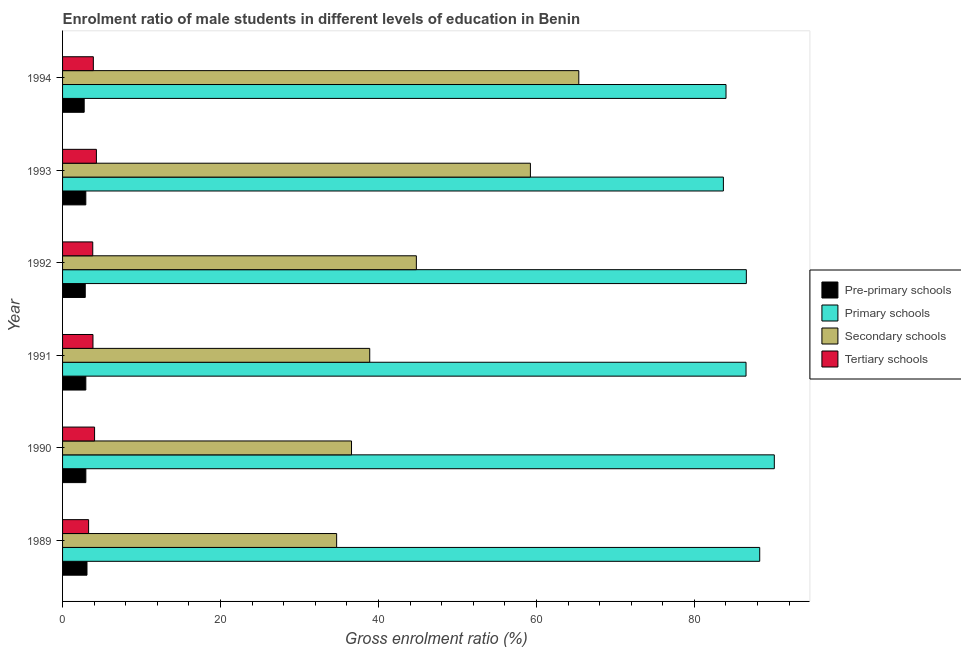How many different coloured bars are there?
Your answer should be compact. 4. How many groups of bars are there?
Offer a terse response. 6. How many bars are there on the 3rd tick from the bottom?
Make the answer very short. 4. What is the label of the 6th group of bars from the top?
Make the answer very short. 1989. In how many cases, is the number of bars for a given year not equal to the number of legend labels?
Your response must be concise. 0. What is the gross enrolment ratio(female) in primary schools in 1990?
Make the answer very short. 90.12. Across all years, what is the maximum gross enrolment ratio(female) in pre-primary schools?
Provide a succinct answer. 3.09. Across all years, what is the minimum gross enrolment ratio(female) in primary schools?
Keep it short and to the point. 83.67. In which year was the gross enrolment ratio(female) in primary schools maximum?
Give a very brief answer. 1990. In which year was the gross enrolment ratio(female) in secondary schools minimum?
Ensure brevity in your answer.  1989. What is the total gross enrolment ratio(female) in primary schools in the graph?
Ensure brevity in your answer.  519.18. What is the difference between the gross enrolment ratio(female) in tertiary schools in 1993 and that in 1994?
Make the answer very short. 0.39. What is the difference between the gross enrolment ratio(female) in pre-primary schools in 1989 and the gross enrolment ratio(female) in tertiary schools in 1994?
Give a very brief answer. -0.8. What is the average gross enrolment ratio(female) in secondary schools per year?
Offer a terse response. 46.6. In the year 1990, what is the difference between the gross enrolment ratio(female) in primary schools and gross enrolment ratio(female) in pre-primary schools?
Offer a terse response. 87.17. What is the ratio of the gross enrolment ratio(female) in tertiary schools in 1990 to that in 1992?
Offer a terse response. 1.06. Is the gross enrolment ratio(female) in primary schools in 1989 less than that in 1993?
Offer a terse response. No. Is the difference between the gross enrolment ratio(female) in tertiary schools in 1991 and 1992 greater than the difference between the gross enrolment ratio(female) in pre-primary schools in 1991 and 1992?
Give a very brief answer. No. What is the difference between the highest and the second highest gross enrolment ratio(female) in primary schools?
Keep it short and to the point. 1.85. What does the 1st bar from the top in 1989 represents?
Provide a succinct answer. Tertiary schools. What does the 4th bar from the bottom in 1993 represents?
Offer a very short reply. Tertiary schools. Is it the case that in every year, the sum of the gross enrolment ratio(female) in pre-primary schools and gross enrolment ratio(female) in primary schools is greater than the gross enrolment ratio(female) in secondary schools?
Keep it short and to the point. Yes. How many bars are there?
Your response must be concise. 24. Does the graph contain grids?
Keep it short and to the point. No. Where does the legend appear in the graph?
Offer a terse response. Center right. How many legend labels are there?
Your answer should be very brief. 4. How are the legend labels stacked?
Ensure brevity in your answer.  Vertical. What is the title of the graph?
Provide a succinct answer. Enrolment ratio of male students in different levels of education in Benin. Does "Third 20% of population" appear as one of the legend labels in the graph?
Ensure brevity in your answer.  No. What is the label or title of the X-axis?
Offer a terse response. Gross enrolment ratio (%). What is the Gross enrolment ratio (%) of Pre-primary schools in 1989?
Give a very brief answer. 3.09. What is the Gross enrolment ratio (%) in Primary schools in 1989?
Your response must be concise. 88.27. What is the Gross enrolment ratio (%) in Secondary schools in 1989?
Make the answer very short. 34.7. What is the Gross enrolment ratio (%) of Tertiary schools in 1989?
Make the answer very short. 3.3. What is the Gross enrolment ratio (%) of Pre-primary schools in 1990?
Make the answer very short. 2.95. What is the Gross enrolment ratio (%) of Primary schools in 1990?
Your answer should be compact. 90.12. What is the Gross enrolment ratio (%) of Secondary schools in 1990?
Your answer should be compact. 36.59. What is the Gross enrolment ratio (%) in Tertiary schools in 1990?
Offer a very short reply. 4.05. What is the Gross enrolment ratio (%) of Pre-primary schools in 1991?
Offer a very short reply. 2.95. What is the Gross enrolment ratio (%) in Primary schools in 1991?
Give a very brief answer. 86.54. What is the Gross enrolment ratio (%) of Secondary schools in 1991?
Your response must be concise. 38.89. What is the Gross enrolment ratio (%) in Tertiary schools in 1991?
Keep it short and to the point. 3.85. What is the Gross enrolment ratio (%) of Pre-primary schools in 1992?
Your response must be concise. 2.87. What is the Gross enrolment ratio (%) in Primary schools in 1992?
Keep it short and to the point. 86.58. What is the Gross enrolment ratio (%) of Secondary schools in 1992?
Give a very brief answer. 44.8. What is the Gross enrolment ratio (%) in Tertiary schools in 1992?
Your response must be concise. 3.82. What is the Gross enrolment ratio (%) in Pre-primary schools in 1993?
Ensure brevity in your answer.  2.94. What is the Gross enrolment ratio (%) in Primary schools in 1993?
Your answer should be very brief. 83.67. What is the Gross enrolment ratio (%) of Secondary schools in 1993?
Your answer should be compact. 59.24. What is the Gross enrolment ratio (%) of Tertiary schools in 1993?
Your response must be concise. 4.29. What is the Gross enrolment ratio (%) of Pre-primary schools in 1994?
Keep it short and to the point. 2.74. What is the Gross enrolment ratio (%) in Primary schools in 1994?
Offer a very short reply. 84. What is the Gross enrolment ratio (%) of Secondary schools in 1994?
Offer a terse response. 65.36. What is the Gross enrolment ratio (%) of Tertiary schools in 1994?
Your answer should be compact. 3.9. Across all years, what is the maximum Gross enrolment ratio (%) in Pre-primary schools?
Ensure brevity in your answer.  3.09. Across all years, what is the maximum Gross enrolment ratio (%) in Primary schools?
Ensure brevity in your answer.  90.12. Across all years, what is the maximum Gross enrolment ratio (%) of Secondary schools?
Your answer should be very brief. 65.36. Across all years, what is the maximum Gross enrolment ratio (%) in Tertiary schools?
Provide a short and direct response. 4.29. Across all years, what is the minimum Gross enrolment ratio (%) in Pre-primary schools?
Your answer should be compact. 2.74. Across all years, what is the minimum Gross enrolment ratio (%) in Primary schools?
Make the answer very short. 83.67. Across all years, what is the minimum Gross enrolment ratio (%) in Secondary schools?
Provide a short and direct response. 34.7. Across all years, what is the minimum Gross enrolment ratio (%) in Tertiary schools?
Offer a very short reply. 3.3. What is the total Gross enrolment ratio (%) in Pre-primary schools in the graph?
Provide a succinct answer. 17.54. What is the total Gross enrolment ratio (%) in Primary schools in the graph?
Your response must be concise. 519.18. What is the total Gross enrolment ratio (%) in Secondary schools in the graph?
Give a very brief answer. 279.58. What is the total Gross enrolment ratio (%) in Tertiary schools in the graph?
Provide a succinct answer. 23.2. What is the difference between the Gross enrolment ratio (%) in Pre-primary schools in 1989 and that in 1990?
Give a very brief answer. 0.14. What is the difference between the Gross enrolment ratio (%) in Primary schools in 1989 and that in 1990?
Keep it short and to the point. -1.85. What is the difference between the Gross enrolment ratio (%) in Secondary schools in 1989 and that in 1990?
Provide a succinct answer. -1.88. What is the difference between the Gross enrolment ratio (%) in Tertiary schools in 1989 and that in 1990?
Your answer should be compact. -0.76. What is the difference between the Gross enrolment ratio (%) of Pre-primary schools in 1989 and that in 1991?
Keep it short and to the point. 0.15. What is the difference between the Gross enrolment ratio (%) in Primary schools in 1989 and that in 1991?
Your answer should be compact. 1.73. What is the difference between the Gross enrolment ratio (%) of Secondary schools in 1989 and that in 1991?
Ensure brevity in your answer.  -4.19. What is the difference between the Gross enrolment ratio (%) of Tertiary schools in 1989 and that in 1991?
Your answer should be compact. -0.55. What is the difference between the Gross enrolment ratio (%) in Pre-primary schools in 1989 and that in 1992?
Give a very brief answer. 0.22. What is the difference between the Gross enrolment ratio (%) of Primary schools in 1989 and that in 1992?
Make the answer very short. 1.7. What is the difference between the Gross enrolment ratio (%) in Secondary schools in 1989 and that in 1992?
Offer a terse response. -10.09. What is the difference between the Gross enrolment ratio (%) of Tertiary schools in 1989 and that in 1992?
Offer a terse response. -0.52. What is the difference between the Gross enrolment ratio (%) in Pre-primary schools in 1989 and that in 1993?
Your answer should be very brief. 0.15. What is the difference between the Gross enrolment ratio (%) in Primary schools in 1989 and that in 1993?
Make the answer very short. 4.6. What is the difference between the Gross enrolment ratio (%) of Secondary schools in 1989 and that in 1993?
Your answer should be compact. -24.53. What is the difference between the Gross enrolment ratio (%) in Tertiary schools in 1989 and that in 1993?
Make the answer very short. -0.99. What is the difference between the Gross enrolment ratio (%) of Pre-primary schools in 1989 and that in 1994?
Offer a terse response. 0.35. What is the difference between the Gross enrolment ratio (%) of Primary schools in 1989 and that in 1994?
Give a very brief answer. 4.27. What is the difference between the Gross enrolment ratio (%) in Secondary schools in 1989 and that in 1994?
Your answer should be very brief. -30.66. What is the difference between the Gross enrolment ratio (%) in Tertiary schools in 1989 and that in 1994?
Your answer should be compact. -0.6. What is the difference between the Gross enrolment ratio (%) in Pre-primary schools in 1990 and that in 1991?
Give a very brief answer. 0. What is the difference between the Gross enrolment ratio (%) in Primary schools in 1990 and that in 1991?
Ensure brevity in your answer.  3.58. What is the difference between the Gross enrolment ratio (%) in Secondary schools in 1990 and that in 1991?
Your response must be concise. -2.31. What is the difference between the Gross enrolment ratio (%) of Tertiary schools in 1990 and that in 1991?
Give a very brief answer. 0.2. What is the difference between the Gross enrolment ratio (%) of Pre-primary schools in 1990 and that in 1992?
Provide a short and direct response. 0.08. What is the difference between the Gross enrolment ratio (%) of Primary schools in 1990 and that in 1992?
Ensure brevity in your answer.  3.54. What is the difference between the Gross enrolment ratio (%) of Secondary schools in 1990 and that in 1992?
Keep it short and to the point. -8.21. What is the difference between the Gross enrolment ratio (%) in Tertiary schools in 1990 and that in 1992?
Provide a succinct answer. 0.23. What is the difference between the Gross enrolment ratio (%) in Pre-primary schools in 1990 and that in 1993?
Your response must be concise. 0. What is the difference between the Gross enrolment ratio (%) in Primary schools in 1990 and that in 1993?
Your response must be concise. 6.45. What is the difference between the Gross enrolment ratio (%) in Secondary schools in 1990 and that in 1993?
Keep it short and to the point. -22.65. What is the difference between the Gross enrolment ratio (%) of Tertiary schools in 1990 and that in 1993?
Your response must be concise. -0.23. What is the difference between the Gross enrolment ratio (%) of Pre-primary schools in 1990 and that in 1994?
Provide a succinct answer. 0.21. What is the difference between the Gross enrolment ratio (%) in Primary schools in 1990 and that in 1994?
Keep it short and to the point. 6.11. What is the difference between the Gross enrolment ratio (%) in Secondary schools in 1990 and that in 1994?
Offer a terse response. -28.78. What is the difference between the Gross enrolment ratio (%) in Tertiary schools in 1990 and that in 1994?
Your response must be concise. 0.16. What is the difference between the Gross enrolment ratio (%) of Pre-primary schools in 1991 and that in 1992?
Your answer should be very brief. 0.07. What is the difference between the Gross enrolment ratio (%) in Primary schools in 1991 and that in 1992?
Keep it short and to the point. -0.04. What is the difference between the Gross enrolment ratio (%) of Secondary schools in 1991 and that in 1992?
Your answer should be compact. -5.9. What is the difference between the Gross enrolment ratio (%) in Tertiary schools in 1991 and that in 1992?
Give a very brief answer. 0.03. What is the difference between the Gross enrolment ratio (%) in Pre-primary schools in 1991 and that in 1993?
Provide a short and direct response. 0. What is the difference between the Gross enrolment ratio (%) in Primary schools in 1991 and that in 1993?
Your answer should be compact. 2.87. What is the difference between the Gross enrolment ratio (%) in Secondary schools in 1991 and that in 1993?
Offer a terse response. -20.34. What is the difference between the Gross enrolment ratio (%) in Tertiary schools in 1991 and that in 1993?
Offer a very short reply. -0.44. What is the difference between the Gross enrolment ratio (%) in Pre-primary schools in 1991 and that in 1994?
Provide a short and direct response. 0.21. What is the difference between the Gross enrolment ratio (%) in Primary schools in 1991 and that in 1994?
Your answer should be very brief. 2.53. What is the difference between the Gross enrolment ratio (%) in Secondary schools in 1991 and that in 1994?
Your response must be concise. -26.47. What is the difference between the Gross enrolment ratio (%) of Tertiary schools in 1991 and that in 1994?
Your answer should be very brief. -0.05. What is the difference between the Gross enrolment ratio (%) of Pre-primary schools in 1992 and that in 1993?
Provide a succinct answer. -0.07. What is the difference between the Gross enrolment ratio (%) in Primary schools in 1992 and that in 1993?
Make the answer very short. 2.9. What is the difference between the Gross enrolment ratio (%) in Secondary schools in 1992 and that in 1993?
Provide a short and direct response. -14.44. What is the difference between the Gross enrolment ratio (%) in Tertiary schools in 1992 and that in 1993?
Keep it short and to the point. -0.46. What is the difference between the Gross enrolment ratio (%) in Pre-primary schools in 1992 and that in 1994?
Your answer should be compact. 0.13. What is the difference between the Gross enrolment ratio (%) of Primary schools in 1992 and that in 1994?
Your response must be concise. 2.57. What is the difference between the Gross enrolment ratio (%) of Secondary schools in 1992 and that in 1994?
Provide a succinct answer. -20.57. What is the difference between the Gross enrolment ratio (%) in Tertiary schools in 1992 and that in 1994?
Your answer should be compact. -0.07. What is the difference between the Gross enrolment ratio (%) of Pre-primary schools in 1993 and that in 1994?
Give a very brief answer. 0.21. What is the difference between the Gross enrolment ratio (%) in Primary schools in 1993 and that in 1994?
Give a very brief answer. -0.33. What is the difference between the Gross enrolment ratio (%) of Secondary schools in 1993 and that in 1994?
Your answer should be compact. -6.13. What is the difference between the Gross enrolment ratio (%) of Tertiary schools in 1993 and that in 1994?
Offer a terse response. 0.39. What is the difference between the Gross enrolment ratio (%) of Pre-primary schools in 1989 and the Gross enrolment ratio (%) of Primary schools in 1990?
Your answer should be very brief. -87.03. What is the difference between the Gross enrolment ratio (%) in Pre-primary schools in 1989 and the Gross enrolment ratio (%) in Secondary schools in 1990?
Provide a short and direct response. -33.49. What is the difference between the Gross enrolment ratio (%) in Pre-primary schools in 1989 and the Gross enrolment ratio (%) in Tertiary schools in 1990?
Make the answer very short. -0.96. What is the difference between the Gross enrolment ratio (%) in Primary schools in 1989 and the Gross enrolment ratio (%) in Secondary schools in 1990?
Your response must be concise. 51.69. What is the difference between the Gross enrolment ratio (%) of Primary schools in 1989 and the Gross enrolment ratio (%) of Tertiary schools in 1990?
Keep it short and to the point. 84.22. What is the difference between the Gross enrolment ratio (%) in Secondary schools in 1989 and the Gross enrolment ratio (%) in Tertiary schools in 1990?
Offer a very short reply. 30.65. What is the difference between the Gross enrolment ratio (%) in Pre-primary schools in 1989 and the Gross enrolment ratio (%) in Primary schools in 1991?
Provide a short and direct response. -83.45. What is the difference between the Gross enrolment ratio (%) in Pre-primary schools in 1989 and the Gross enrolment ratio (%) in Secondary schools in 1991?
Give a very brief answer. -35.8. What is the difference between the Gross enrolment ratio (%) of Pre-primary schools in 1989 and the Gross enrolment ratio (%) of Tertiary schools in 1991?
Your answer should be very brief. -0.76. What is the difference between the Gross enrolment ratio (%) in Primary schools in 1989 and the Gross enrolment ratio (%) in Secondary schools in 1991?
Provide a succinct answer. 49.38. What is the difference between the Gross enrolment ratio (%) of Primary schools in 1989 and the Gross enrolment ratio (%) of Tertiary schools in 1991?
Give a very brief answer. 84.42. What is the difference between the Gross enrolment ratio (%) of Secondary schools in 1989 and the Gross enrolment ratio (%) of Tertiary schools in 1991?
Offer a very short reply. 30.85. What is the difference between the Gross enrolment ratio (%) in Pre-primary schools in 1989 and the Gross enrolment ratio (%) in Primary schools in 1992?
Your answer should be compact. -83.48. What is the difference between the Gross enrolment ratio (%) of Pre-primary schools in 1989 and the Gross enrolment ratio (%) of Secondary schools in 1992?
Your answer should be very brief. -41.7. What is the difference between the Gross enrolment ratio (%) in Pre-primary schools in 1989 and the Gross enrolment ratio (%) in Tertiary schools in 1992?
Your response must be concise. -0.73. What is the difference between the Gross enrolment ratio (%) of Primary schools in 1989 and the Gross enrolment ratio (%) of Secondary schools in 1992?
Keep it short and to the point. 43.48. What is the difference between the Gross enrolment ratio (%) of Primary schools in 1989 and the Gross enrolment ratio (%) of Tertiary schools in 1992?
Offer a very short reply. 84.45. What is the difference between the Gross enrolment ratio (%) in Secondary schools in 1989 and the Gross enrolment ratio (%) in Tertiary schools in 1992?
Your response must be concise. 30.88. What is the difference between the Gross enrolment ratio (%) in Pre-primary schools in 1989 and the Gross enrolment ratio (%) in Primary schools in 1993?
Provide a short and direct response. -80.58. What is the difference between the Gross enrolment ratio (%) of Pre-primary schools in 1989 and the Gross enrolment ratio (%) of Secondary schools in 1993?
Keep it short and to the point. -56.14. What is the difference between the Gross enrolment ratio (%) in Pre-primary schools in 1989 and the Gross enrolment ratio (%) in Tertiary schools in 1993?
Your answer should be compact. -1.19. What is the difference between the Gross enrolment ratio (%) of Primary schools in 1989 and the Gross enrolment ratio (%) of Secondary schools in 1993?
Your response must be concise. 29.04. What is the difference between the Gross enrolment ratio (%) of Primary schools in 1989 and the Gross enrolment ratio (%) of Tertiary schools in 1993?
Provide a short and direct response. 83.99. What is the difference between the Gross enrolment ratio (%) in Secondary schools in 1989 and the Gross enrolment ratio (%) in Tertiary schools in 1993?
Your response must be concise. 30.42. What is the difference between the Gross enrolment ratio (%) in Pre-primary schools in 1989 and the Gross enrolment ratio (%) in Primary schools in 1994?
Your answer should be compact. -80.91. What is the difference between the Gross enrolment ratio (%) of Pre-primary schools in 1989 and the Gross enrolment ratio (%) of Secondary schools in 1994?
Ensure brevity in your answer.  -62.27. What is the difference between the Gross enrolment ratio (%) in Pre-primary schools in 1989 and the Gross enrolment ratio (%) in Tertiary schools in 1994?
Your response must be concise. -0.8. What is the difference between the Gross enrolment ratio (%) of Primary schools in 1989 and the Gross enrolment ratio (%) of Secondary schools in 1994?
Keep it short and to the point. 22.91. What is the difference between the Gross enrolment ratio (%) of Primary schools in 1989 and the Gross enrolment ratio (%) of Tertiary schools in 1994?
Your answer should be compact. 84.38. What is the difference between the Gross enrolment ratio (%) in Secondary schools in 1989 and the Gross enrolment ratio (%) in Tertiary schools in 1994?
Offer a terse response. 30.81. What is the difference between the Gross enrolment ratio (%) in Pre-primary schools in 1990 and the Gross enrolment ratio (%) in Primary schools in 1991?
Give a very brief answer. -83.59. What is the difference between the Gross enrolment ratio (%) of Pre-primary schools in 1990 and the Gross enrolment ratio (%) of Secondary schools in 1991?
Your answer should be very brief. -35.95. What is the difference between the Gross enrolment ratio (%) in Pre-primary schools in 1990 and the Gross enrolment ratio (%) in Tertiary schools in 1991?
Offer a terse response. -0.9. What is the difference between the Gross enrolment ratio (%) of Primary schools in 1990 and the Gross enrolment ratio (%) of Secondary schools in 1991?
Ensure brevity in your answer.  51.23. What is the difference between the Gross enrolment ratio (%) of Primary schools in 1990 and the Gross enrolment ratio (%) of Tertiary schools in 1991?
Offer a very short reply. 86.27. What is the difference between the Gross enrolment ratio (%) of Secondary schools in 1990 and the Gross enrolment ratio (%) of Tertiary schools in 1991?
Your answer should be very brief. 32.74. What is the difference between the Gross enrolment ratio (%) in Pre-primary schools in 1990 and the Gross enrolment ratio (%) in Primary schools in 1992?
Offer a very short reply. -83.63. What is the difference between the Gross enrolment ratio (%) in Pre-primary schools in 1990 and the Gross enrolment ratio (%) in Secondary schools in 1992?
Provide a succinct answer. -41.85. What is the difference between the Gross enrolment ratio (%) in Pre-primary schools in 1990 and the Gross enrolment ratio (%) in Tertiary schools in 1992?
Offer a very short reply. -0.87. What is the difference between the Gross enrolment ratio (%) of Primary schools in 1990 and the Gross enrolment ratio (%) of Secondary schools in 1992?
Offer a very short reply. 45.32. What is the difference between the Gross enrolment ratio (%) in Primary schools in 1990 and the Gross enrolment ratio (%) in Tertiary schools in 1992?
Ensure brevity in your answer.  86.3. What is the difference between the Gross enrolment ratio (%) of Secondary schools in 1990 and the Gross enrolment ratio (%) of Tertiary schools in 1992?
Your answer should be compact. 32.76. What is the difference between the Gross enrolment ratio (%) in Pre-primary schools in 1990 and the Gross enrolment ratio (%) in Primary schools in 1993?
Keep it short and to the point. -80.72. What is the difference between the Gross enrolment ratio (%) in Pre-primary schools in 1990 and the Gross enrolment ratio (%) in Secondary schools in 1993?
Offer a terse response. -56.29. What is the difference between the Gross enrolment ratio (%) of Pre-primary schools in 1990 and the Gross enrolment ratio (%) of Tertiary schools in 1993?
Keep it short and to the point. -1.34. What is the difference between the Gross enrolment ratio (%) of Primary schools in 1990 and the Gross enrolment ratio (%) of Secondary schools in 1993?
Give a very brief answer. 30.88. What is the difference between the Gross enrolment ratio (%) in Primary schools in 1990 and the Gross enrolment ratio (%) in Tertiary schools in 1993?
Your response must be concise. 85.83. What is the difference between the Gross enrolment ratio (%) of Secondary schools in 1990 and the Gross enrolment ratio (%) of Tertiary schools in 1993?
Your answer should be compact. 32.3. What is the difference between the Gross enrolment ratio (%) of Pre-primary schools in 1990 and the Gross enrolment ratio (%) of Primary schools in 1994?
Keep it short and to the point. -81.06. What is the difference between the Gross enrolment ratio (%) in Pre-primary schools in 1990 and the Gross enrolment ratio (%) in Secondary schools in 1994?
Your answer should be compact. -62.42. What is the difference between the Gross enrolment ratio (%) of Pre-primary schools in 1990 and the Gross enrolment ratio (%) of Tertiary schools in 1994?
Ensure brevity in your answer.  -0.95. What is the difference between the Gross enrolment ratio (%) in Primary schools in 1990 and the Gross enrolment ratio (%) in Secondary schools in 1994?
Make the answer very short. 24.76. What is the difference between the Gross enrolment ratio (%) in Primary schools in 1990 and the Gross enrolment ratio (%) in Tertiary schools in 1994?
Offer a very short reply. 86.22. What is the difference between the Gross enrolment ratio (%) in Secondary schools in 1990 and the Gross enrolment ratio (%) in Tertiary schools in 1994?
Provide a short and direct response. 32.69. What is the difference between the Gross enrolment ratio (%) of Pre-primary schools in 1991 and the Gross enrolment ratio (%) of Primary schools in 1992?
Provide a short and direct response. -83.63. What is the difference between the Gross enrolment ratio (%) in Pre-primary schools in 1991 and the Gross enrolment ratio (%) in Secondary schools in 1992?
Ensure brevity in your answer.  -41.85. What is the difference between the Gross enrolment ratio (%) in Pre-primary schools in 1991 and the Gross enrolment ratio (%) in Tertiary schools in 1992?
Provide a short and direct response. -0.88. What is the difference between the Gross enrolment ratio (%) of Primary schools in 1991 and the Gross enrolment ratio (%) of Secondary schools in 1992?
Offer a very short reply. 41.74. What is the difference between the Gross enrolment ratio (%) in Primary schools in 1991 and the Gross enrolment ratio (%) in Tertiary schools in 1992?
Your answer should be very brief. 82.72. What is the difference between the Gross enrolment ratio (%) of Secondary schools in 1991 and the Gross enrolment ratio (%) of Tertiary schools in 1992?
Offer a very short reply. 35.07. What is the difference between the Gross enrolment ratio (%) in Pre-primary schools in 1991 and the Gross enrolment ratio (%) in Primary schools in 1993?
Offer a terse response. -80.73. What is the difference between the Gross enrolment ratio (%) in Pre-primary schools in 1991 and the Gross enrolment ratio (%) in Secondary schools in 1993?
Ensure brevity in your answer.  -56.29. What is the difference between the Gross enrolment ratio (%) of Pre-primary schools in 1991 and the Gross enrolment ratio (%) of Tertiary schools in 1993?
Make the answer very short. -1.34. What is the difference between the Gross enrolment ratio (%) in Primary schools in 1991 and the Gross enrolment ratio (%) in Secondary schools in 1993?
Your answer should be compact. 27.3. What is the difference between the Gross enrolment ratio (%) of Primary schools in 1991 and the Gross enrolment ratio (%) of Tertiary schools in 1993?
Ensure brevity in your answer.  82.25. What is the difference between the Gross enrolment ratio (%) of Secondary schools in 1991 and the Gross enrolment ratio (%) of Tertiary schools in 1993?
Offer a very short reply. 34.61. What is the difference between the Gross enrolment ratio (%) in Pre-primary schools in 1991 and the Gross enrolment ratio (%) in Primary schools in 1994?
Provide a succinct answer. -81.06. What is the difference between the Gross enrolment ratio (%) in Pre-primary schools in 1991 and the Gross enrolment ratio (%) in Secondary schools in 1994?
Your response must be concise. -62.42. What is the difference between the Gross enrolment ratio (%) in Pre-primary schools in 1991 and the Gross enrolment ratio (%) in Tertiary schools in 1994?
Provide a short and direct response. -0.95. What is the difference between the Gross enrolment ratio (%) in Primary schools in 1991 and the Gross enrolment ratio (%) in Secondary schools in 1994?
Your answer should be very brief. 21.17. What is the difference between the Gross enrolment ratio (%) of Primary schools in 1991 and the Gross enrolment ratio (%) of Tertiary schools in 1994?
Your answer should be very brief. 82.64. What is the difference between the Gross enrolment ratio (%) in Secondary schools in 1991 and the Gross enrolment ratio (%) in Tertiary schools in 1994?
Provide a short and direct response. 35. What is the difference between the Gross enrolment ratio (%) in Pre-primary schools in 1992 and the Gross enrolment ratio (%) in Primary schools in 1993?
Ensure brevity in your answer.  -80.8. What is the difference between the Gross enrolment ratio (%) in Pre-primary schools in 1992 and the Gross enrolment ratio (%) in Secondary schools in 1993?
Offer a terse response. -56.37. What is the difference between the Gross enrolment ratio (%) in Pre-primary schools in 1992 and the Gross enrolment ratio (%) in Tertiary schools in 1993?
Your answer should be very brief. -1.41. What is the difference between the Gross enrolment ratio (%) in Primary schools in 1992 and the Gross enrolment ratio (%) in Secondary schools in 1993?
Ensure brevity in your answer.  27.34. What is the difference between the Gross enrolment ratio (%) in Primary schools in 1992 and the Gross enrolment ratio (%) in Tertiary schools in 1993?
Give a very brief answer. 82.29. What is the difference between the Gross enrolment ratio (%) in Secondary schools in 1992 and the Gross enrolment ratio (%) in Tertiary schools in 1993?
Provide a succinct answer. 40.51. What is the difference between the Gross enrolment ratio (%) in Pre-primary schools in 1992 and the Gross enrolment ratio (%) in Primary schools in 1994?
Keep it short and to the point. -81.13. What is the difference between the Gross enrolment ratio (%) of Pre-primary schools in 1992 and the Gross enrolment ratio (%) of Secondary schools in 1994?
Your response must be concise. -62.49. What is the difference between the Gross enrolment ratio (%) in Pre-primary schools in 1992 and the Gross enrolment ratio (%) in Tertiary schools in 1994?
Ensure brevity in your answer.  -1.03. What is the difference between the Gross enrolment ratio (%) in Primary schools in 1992 and the Gross enrolment ratio (%) in Secondary schools in 1994?
Offer a terse response. 21.21. What is the difference between the Gross enrolment ratio (%) in Primary schools in 1992 and the Gross enrolment ratio (%) in Tertiary schools in 1994?
Keep it short and to the point. 82.68. What is the difference between the Gross enrolment ratio (%) in Secondary schools in 1992 and the Gross enrolment ratio (%) in Tertiary schools in 1994?
Make the answer very short. 40.9. What is the difference between the Gross enrolment ratio (%) in Pre-primary schools in 1993 and the Gross enrolment ratio (%) in Primary schools in 1994?
Your answer should be very brief. -81.06. What is the difference between the Gross enrolment ratio (%) of Pre-primary schools in 1993 and the Gross enrolment ratio (%) of Secondary schools in 1994?
Your response must be concise. -62.42. What is the difference between the Gross enrolment ratio (%) in Pre-primary schools in 1993 and the Gross enrolment ratio (%) in Tertiary schools in 1994?
Give a very brief answer. -0.95. What is the difference between the Gross enrolment ratio (%) of Primary schools in 1993 and the Gross enrolment ratio (%) of Secondary schools in 1994?
Your response must be concise. 18.31. What is the difference between the Gross enrolment ratio (%) in Primary schools in 1993 and the Gross enrolment ratio (%) in Tertiary schools in 1994?
Your answer should be very brief. 79.78. What is the difference between the Gross enrolment ratio (%) in Secondary schools in 1993 and the Gross enrolment ratio (%) in Tertiary schools in 1994?
Your answer should be compact. 55.34. What is the average Gross enrolment ratio (%) of Pre-primary schools per year?
Offer a terse response. 2.92. What is the average Gross enrolment ratio (%) of Primary schools per year?
Ensure brevity in your answer.  86.53. What is the average Gross enrolment ratio (%) of Secondary schools per year?
Give a very brief answer. 46.6. What is the average Gross enrolment ratio (%) in Tertiary schools per year?
Provide a short and direct response. 3.87. In the year 1989, what is the difference between the Gross enrolment ratio (%) in Pre-primary schools and Gross enrolment ratio (%) in Primary schools?
Offer a very short reply. -85.18. In the year 1989, what is the difference between the Gross enrolment ratio (%) of Pre-primary schools and Gross enrolment ratio (%) of Secondary schools?
Offer a very short reply. -31.61. In the year 1989, what is the difference between the Gross enrolment ratio (%) of Pre-primary schools and Gross enrolment ratio (%) of Tertiary schools?
Make the answer very short. -0.21. In the year 1989, what is the difference between the Gross enrolment ratio (%) in Primary schools and Gross enrolment ratio (%) in Secondary schools?
Make the answer very short. 53.57. In the year 1989, what is the difference between the Gross enrolment ratio (%) in Primary schools and Gross enrolment ratio (%) in Tertiary schools?
Give a very brief answer. 84.97. In the year 1989, what is the difference between the Gross enrolment ratio (%) in Secondary schools and Gross enrolment ratio (%) in Tertiary schools?
Your answer should be very brief. 31.41. In the year 1990, what is the difference between the Gross enrolment ratio (%) of Pre-primary schools and Gross enrolment ratio (%) of Primary schools?
Provide a short and direct response. -87.17. In the year 1990, what is the difference between the Gross enrolment ratio (%) of Pre-primary schools and Gross enrolment ratio (%) of Secondary schools?
Ensure brevity in your answer.  -33.64. In the year 1990, what is the difference between the Gross enrolment ratio (%) in Pre-primary schools and Gross enrolment ratio (%) in Tertiary schools?
Your response must be concise. -1.11. In the year 1990, what is the difference between the Gross enrolment ratio (%) in Primary schools and Gross enrolment ratio (%) in Secondary schools?
Offer a very short reply. 53.53. In the year 1990, what is the difference between the Gross enrolment ratio (%) in Primary schools and Gross enrolment ratio (%) in Tertiary schools?
Make the answer very short. 86.07. In the year 1990, what is the difference between the Gross enrolment ratio (%) in Secondary schools and Gross enrolment ratio (%) in Tertiary schools?
Provide a succinct answer. 32.53. In the year 1991, what is the difference between the Gross enrolment ratio (%) in Pre-primary schools and Gross enrolment ratio (%) in Primary schools?
Keep it short and to the point. -83.59. In the year 1991, what is the difference between the Gross enrolment ratio (%) in Pre-primary schools and Gross enrolment ratio (%) in Secondary schools?
Keep it short and to the point. -35.95. In the year 1991, what is the difference between the Gross enrolment ratio (%) of Pre-primary schools and Gross enrolment ratio (%) of Tertiary schools?
Your answer should be very brief. -0.9. In the year 1991, what is the difference between the Gross enrolment ratio (%) in Primary schools and Gross enrolment ratio (%) in Secondary schools?
Ensure brevity in your answer.  47.65. In the year 1991, what is the difference between the Gross enrolment ratio (%) in Primary schools and Gross enrolment ratio (%) in Tertiary schools?
Your response must be concise. 82.69. In the year 1991, what is the difference between the Gross enrolment ratio (%) in Secondary schools and Gross enrolment ratio (%) in Tertiary schools?
Provide a short and direct response. 35.04. In the year 1992, what is the difference between the Gross enrolment ratio (%) in Pre-primary schools and Gross enrolment ratio (%) in Primary schools?
Offer a terse response. -83.71. In the year 1992, what is the difference between the Gross enrolment ratio (%) of Pre-primary schools and Gross enrolment ratio (%) of Secondary schools?
Your answer should be very brief. -41.92. In the year 1992, what is the difference between the Gross enrolment ratio (%) in Pre-primary schools and Gross enrolment ratio (%) in Tertiary schools?
Keep it short and to the point. -0.95. In the year 1992, what is the difference between the Gross enrolment ratio (%) of Primary schools and Gross enrolment ratio (%) of Secondary schools?
Keep it short and to the point. 41.78. In the year 1992, what is the difference between the Gross enrolment ratio (%) in Primary schools and Gross enrolment ratio (%) in Tertiary schools?
Keep it short and to the point. 82.75. In the year 1992, what is the difference between the Gross enrolment ratio (%) in Secondary schools and Gross enrolment ratio (%) in Tertiary schools?
Provide a short and direct response. 40.97. In the year 1993, what is the difference between the Gross enrolment ratio (%) of Pre-primary schools and Gross enrolment ratio (%) of Primary schools?
Your answer should be very brief. -80.73. In the year 1993, what is the difference between the Gross enrolment ratio (%) in Pre-primary schools and Gross enrolment ratio (%) in Secondary schools?
Keep it short and to the point. -56.29. In the year 1993, what is the difference between the Gross enrolment ratio (%) in Pre-primary schools and Gross enrolment ratio (%) in Tertiary schools?
Provide a short and direct response. -1.34. In the year 1993, what is the difference between the Gross enrolment ratio (%) of Primary schools and Gross enrolment ratio (%) of Secondary schools?
Offer a very short reply. 24.44. In the year 1993, what is the difference between the Gross enrolment ratio (%) in Primary schools and Gross enrolment ratio (%) in Tertiary schools?
Offer a very short reply. 79.39. In the year 1993, what is the difference between the Gross enrolment ratio (%) of Secondary schools and Gross enrolment ratio (%) of Tertiary schools?
Keep it short and to the point. 54.95. In the year 1994, what is the difference between the Gross enrolment ratio (%) in Pre-primary schools and Gross enrolment ratio (%) in Primary schools?
Offer a very short reply. -81.27. In the year 1994, what is the difference between the Gross enrolment ratio (%) of Pre-primary schools and Gross enrolment ratio (%) of Secondary schools?
Your response must be concise. -62.63. In the year 1994, what is the difference between the Gross enrolment ratio (%) of Pre-primary schools and Gross enrolment ratio (%) of Tertiary schools?
Your answer should be compact. -1.16. In the year 1994, what is the difference between the Gross enrolment ratio (%) of Primary schools and Gross enrolment ratio (%) of Secondary schools?
Your response must be concise. 18.64. In the year 1994, what is the difference between the Gross enrolment ratio (%) in Primary schools and Gross enrolment ratio (%) in Tertiary schools?
Your answer should be compact. 80.11. In the year 1994, what is the difference between the Gross enrolment ratio (%) of Secondary schools and Gross enrolment ratio (%) of Tertiary schools?
Provide a short and direct response. 61.47. What is the ratio of the Gross enrolment ratio (%) of Pre-primary schools in 1989 to that in 1990?
Provide a succinct answer. 1.05. What is the ratio of the Gross enrolment ratio (%) in Primary schools in 1989 to that in 1990?
Give a very brief answer. 0.98. What is the ratio of the Gross enrolment ratio (%) in Secondary schools in 1989 to that in 1990?
Your answer should be very brief. 0.95. What is the ratio of the Gross enrolment ratio (%) in Tertiary schools in 1989 to that in 1990?
Make the answer very short. 0.81. What is the ratio of the Gross enrolment ratio (%) in Pre-primary schools in 1989 to that in 1991?
Offer a terse response. 1.05. What is the ratio of the Gross enrolment ratio (%) of Secondary schools in 1989 to that in 1991?
Your answer should be compact. 0.89. What is the ratio of the Gross enrolment ratio (%) in Tertiary schools in 1989 to that in 1991?
Your response must be concise. 0.86. What is the ratio of the Gross enrolment ratio (%) of Primary schools in 1989 to that in 1992?
Make the answer very short. 1.02. What is the ratio of the Gross enrolment ratio (%) of Secondary schools in 1989 to that in 1992?
Make the answer very short. 0.77. What is the ratio of the Gross enrolment ratio (%) of Tertiary schools in 1989 to that in 1992?
Give a very brief answer. 0.86. What is the ratio of the Gross enrolment ratio (%) in Pre-primary schools in 1989 to that in 1993?
Provide a succinct answer. 1.05. What is the ratio of the Gross enrolment ratio (%) in Primary schools in 1989 to that in 1993?
Offer a very short reply. 1.05. What is the ratio of the Gross enrolment ratio (%) of Secondary schools in 1989 to that in 1993?
Offer a very short reply. 0.59. What is the ratio of the Gross enrolment ratio (%) in Tertiary schools in 1989 to that in 1993?
Offer a terse response. 0.77. What is the ratio of the Gross enrolment ratio (%) in Pre-primary schools in 1989 to that in 1994?
Your answer should be very brief. 1.13. What is the ratio of the Gross enrolment ratio (%) of Primary schools in 1989 to that in 1994?
Keep it short and to the point. 1.05. What is the ratio of the Gross enrolment ratio (%) in Secondary schools in 1989 to that in 1994?
Give a very brief answer. 0.53. What is the ratio of the Gross enrolment ratio (%) in Tertiary schools in 1989 to that in 1994?
Your answer should be compact. 0.85. What is the ratio of the Gross enrolment ratio (%) in Primary schools in 1990 to that in 1991?
Your answer should be compact. 1.04. What is the ratio of the Gross enrolment ratio (%) of Secondary schools in 1990 to that in 1991?
Provide a short and direct response. 0.94. What is the ratio of the Gross enrolment ratio (%) of Tertiary schools in 1990 to that in 1991?
Make the answer very short. 1.05. What is the ratio of the Gross enrolment ratio (%) in Pre-primary schools in 1990 to that in 1992?
Provide a succinct answer. 1.03. What is the ratio of the Gross enrolment ratio (%) in Primary schools in 1990 to that in 1992?
Give a very brief answer. 1.04. What is the ratio of the Gross enrolment ratio (%) in Secondary schools in 1990 to that in 1992?
Keep it short and to the point. 0.82. What is the ratio of the Gross enrolment ratio (%) of Tertiary schools in 1990 to that in 1992?
Keep it short and to the point. 1.06. What is the ratio of the Gross enrolment ratio (%) in Pre-primary schools in 1990 to that in 1993?
Ensure brevity in your answer.  1. What is the ratio of the Gross enrolment ratio (%) of Primary schools in 1990 to that in 1993?
Give a very brief answer. 1.08. What is the ratio of the Gross enrolment ratio (%) of Secondary schools in 1990 to that in 1993?
Ensure brevity in your answer.  0.62. What is the ratio of the Gross enrolment ratio (%) in Tertiary schools in 1990 to that in 1993?
Offer a terse response. 0.95. What is the ratio of the Gross enrolment ratio (%) of Pre-primary schools in 1990 to that in 1994?
Ensure brevity in your answer.  1.08. What is the ratio of the Gross enrolment ratio (%) in Primary schools in 1990 to that in 1994?
Keep it short and to the point. 1.07. What is the ratio of the Gross enrolment ratio (%) in Secondary schools in 1990 to that in 1994?
Offer a terse response. 0.56. What is the ratio of the Gross enrolment ratio (%) in Pre-primary schools in 1991 to that in 1992?
Keep it short and to the point. 1.03. What is the ratio of the Gross enrolment ratio (%) in Secondary schools in 1991 to that in 1992?
Offer a very short reply. 0.87. What is the ratio of the Gross enrolment ratio (%) of Tertiary schools in 1991 to that in 1992?
Offer a terse response. 1.01. What is the ratio of the Gross enrolment ratio (%) in Pre-primary schools in 1991 to that in 1993?
Your answer should be compact. 1. What is the ratio of the Gross enrolment ratio (%) of Primary schools in 1991 to that in 1993?
Ensure brevity in your answer.  1.03. What is the ratio of the Gross enrolment ratio (%) of Secondary schools in 1991 to that in 1993?
Make the answer very short. 0.66. What is the ratio of the Gross enrolment ratio (%) of Tertiary schools in 1991 to that in 1993?
Your answer should be compact. 0.9. What is the ratio of the Gross enrolment ratio (%) of Pre-primary schools in 1991 to that in 1994?
Ensure brevity in your answer.  1.08. What is the ratio of the Gross enrolment ratio (%) in Primary schools in 1991 to that in 1994?
Provide a succinct answer. 1.03. What is the ratio of the Gross enrolment ratio (%) of Secondary schools in 1991 to that in 1994?
Your answer should be very brief. 0.59. What is the ratio of the Gross enrolment ratio (%) of Tertiary schools in 1991 to that in 1994?
Your answer should be very brief. 0.99. What is the ratio of the Gross enrolment ratio (%) of Pre-primary schools in 1992 to that in 1993?
Offer a very short reply. 0.98. What is the ratio of the Gross enrolment ratio (%) in Primary schools in 1992 to that in 1993?
Your response must be concise. 1.03. What is the ratio of the Gross enrolment ratio (%) of Secondary schools in 1992 to that in 1993?
Your response must be concise. 0.76. What is the ratio of the Gross enrolment ratio (%) in Tertiary schools in 1992 to that in 1993?
Make the answer very short. 0.89. What is the ratio of the Gross enrolment ratio (%) of Pre-primary schools in 1992 to that in 1994?
Your response must be concise. 1.05. What is the ratio of the Gross enrolment ratio (%) of Primary schools in 1992 to that in 1994?
Provide a short and direct response. 1.03. What is the ratio of the Gross enrolment ratio (%) of Secondary schools in 1992 to that in 1994?
Your response must be concise. 0.69. What is the ratio of the Gross enrolment ratio (%) of Tertiary schools in 1992 to that in 1994?
Provide a succinct answer. 0.98. What is the ratio of the Gross enrolment ratio (%) of Pre-primary schools in 1993 to that in 1994?
Keep it short and to the point. 1.07. What is the ratio of the Gross enrolment ratio (%) of Primary schools in 1993 to that in 1994?
Your answer should be compact. 1. What is the ratio of the Gross enrolment ratio (%) in Secondary schools in 1993 to that in 1994?
Provide a succinct answer. 0.91. What is the ratio of the Gross enrolment ratio (%) in Tertiary schools in 1993 to that in 1994?
Your response must be concise. 1.1. What is the difference between the highest and the second highest Gross enrolment ratio (%) of Pre-primary schools?
Your answer should be compact. 0.14. What is the difference between the highest and the second highest Gross enrolment ratio (%) in Primary schools?
Your response must be concise. 1.85. What is the difference between the highest and the second highest Gross enrolment ratio (%) of Secondary schools?
Give a very brief answer. 6.13. What is the difference between the highest and the second highest Gross enrolment ratio (%) in Tertiary schools?
Your answer should be very brief. 0.23. What is the difference between the highest and the lowest Gross enrolment ratio (%) of Pre-primary schools?
Offer a very short reply. 0.35. What is the difference between the highest and the lowest Gross enrolment ratio (%) of Primary schools?
Ensure brevity in your answer.  6.45. What is the difference between the highest and the lowest Gross enrolment ratio (%) in Secondary schools?
Provide a short and direct response. 30.66. What is the difference between the highest and the lowest Gross enrolment ratio (%) in Tertiary schools?
Provide a succinct answer. 0.99. 